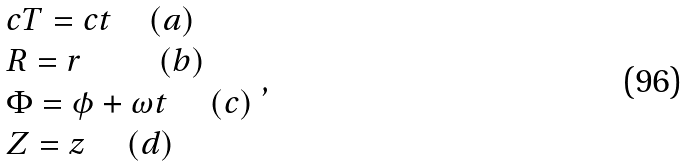<formula> <loc_0><loc_0><loc_500><loc_500>\begin{array} { l } c T = c t \quad ( a ) \\ R = r \quad \, \quad ( b ) \\ \Phi = \phi + \omega t \quad \, ( c ) \\ Z = z \quad \, ( d ) \\ \end{array} ,</formula> 